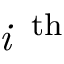<formula> <loc_0><loc_0><loc_500><loc_500>i \, ^ { t h }</formula> 